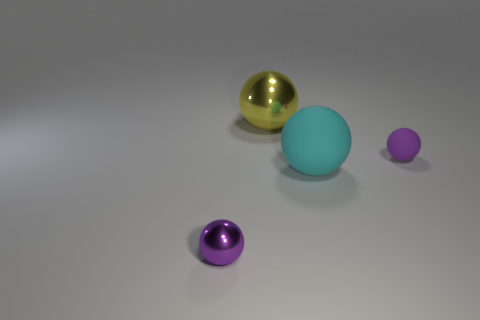Subtract all large yellow metallic spheres. How many spheres are left? 3 Add 4 tiny purple rubber blocks. How many objects exist? 8 Subtract all yellow cylinders. How many purple balls are left? 2 Subtract all cyan balls. How many balls are left? 3 Subtract 1 yellow balls. How many objects are left? 3 Subtract 3 balls. How many balls are left? 1 Subtract all brown spheres. Subtract all cyan blocks. How many spheres are left? 4 Subtract all large blue rubber cylinders. Subtract all large metallic spheres. How many objects are left? 3 Add 2 tiny purple things. How many tiny purple things are left? 4 Add 3 metallic objects. How many metallic objects exist? 5 